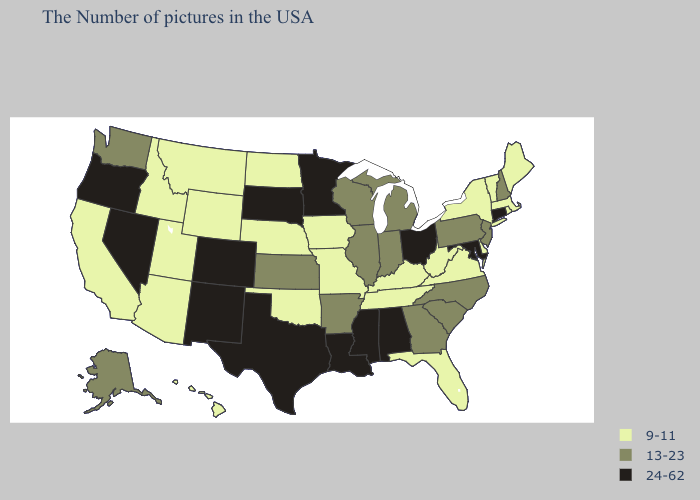What is the lowest value in states that border Kentucky?
Short answer required. 9-11. Name the states that have a value in the range 9-11?
Give a very brief answer. Maine, Massachusetts, Rhode Island, Vermont, New York, Delaware, Virginia, West Virginia, Florida, Kentucky, Tennessee, Missouri, Iowa, Nebraska, Oklahoma, North Dakota, Wyoming, Utah, Montana, Arizona, Idaho, California, Hawaii. What is the highest value in states that border Oklahoma?
Quick response, please. 24-62. What is the lowest value in the USA?
Keep it brief. 9-11. Name the states that have a value in the range 9-11?
Concise answer only. Maine, Massachusetts, Rhode Island, Vermont, New York, Delaware, Virginia, West Virginia, Florida, Kentucky, Tennessee, Missouri, Iowa, Nebraska, Oklahoma, North Dakota, Wyoming, Utah, Montana, Arizona, Idaho, California, Hawaii. Name the states that have a value in the range 13-23?
Keep it brief. New Hampshire, New Jersey, Pennsylvania, North Carolina, South Carolina, Georgia, Michigan, Indiana, Wisconsin, Illinois, Arkansas, Kansas, Washington, Alaska. Name the states that have a value in the range 24-62?
Concise answer only. Connecticut, Maryland, Ohio, Alabama, Mississippi, Louisiana, Minnesota, Texas, South Dakota, Colorado, New Mexico, Nevada, Oregon. Does Alabama have the lowest value in the South?
Give a very brief answer. No. What is the value of Kansas?
Quick response, please. 13-23. What is the value of Maine?
Keep it brief. 9-11. What is the value of Mississippi?
Keep it brief. 24-62. What is the lowest value in the MidWest?
Quick response, please. 9-11. What is the value of Rhode Island?
Be succinct. 9-11. Name the states that have a value in the range 24-62?
Be succinct. Connecticut, Maryland, Ohio, Alabama, Mississippi, Louisiana, Minnesota, Texas, South Dakota, Colorado, New Mexico, Nevada, Oregon. What is the value of Rhode Island?
Quick response, please. 9-11. 